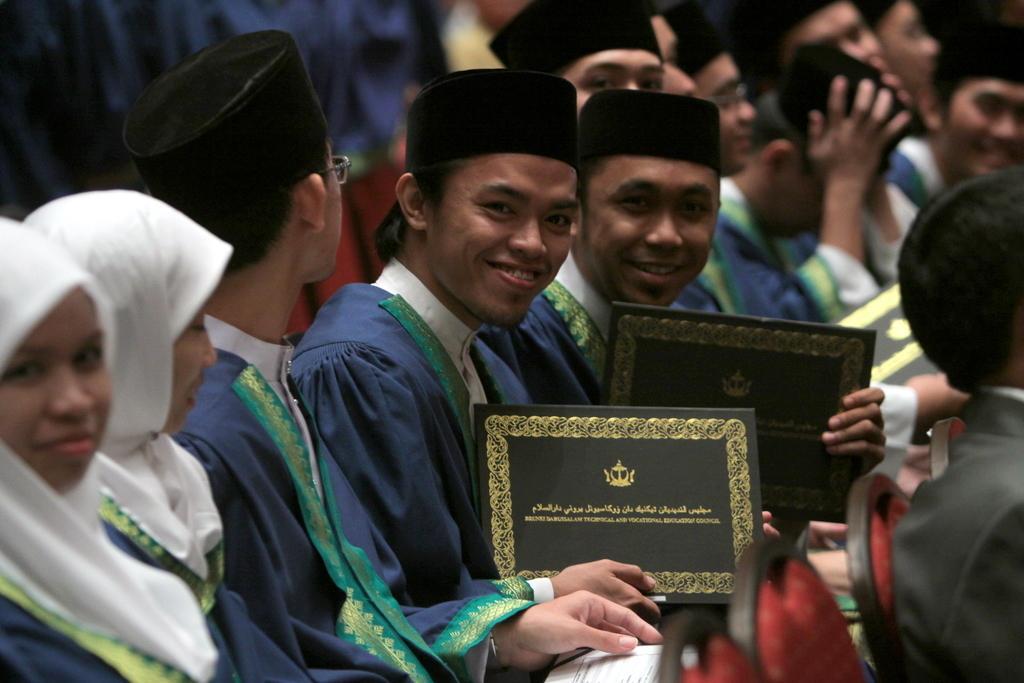Please provide a concise description of this image. In this image, there are a few people. Among them, some people are holding some objects. We can also see some chairs. 